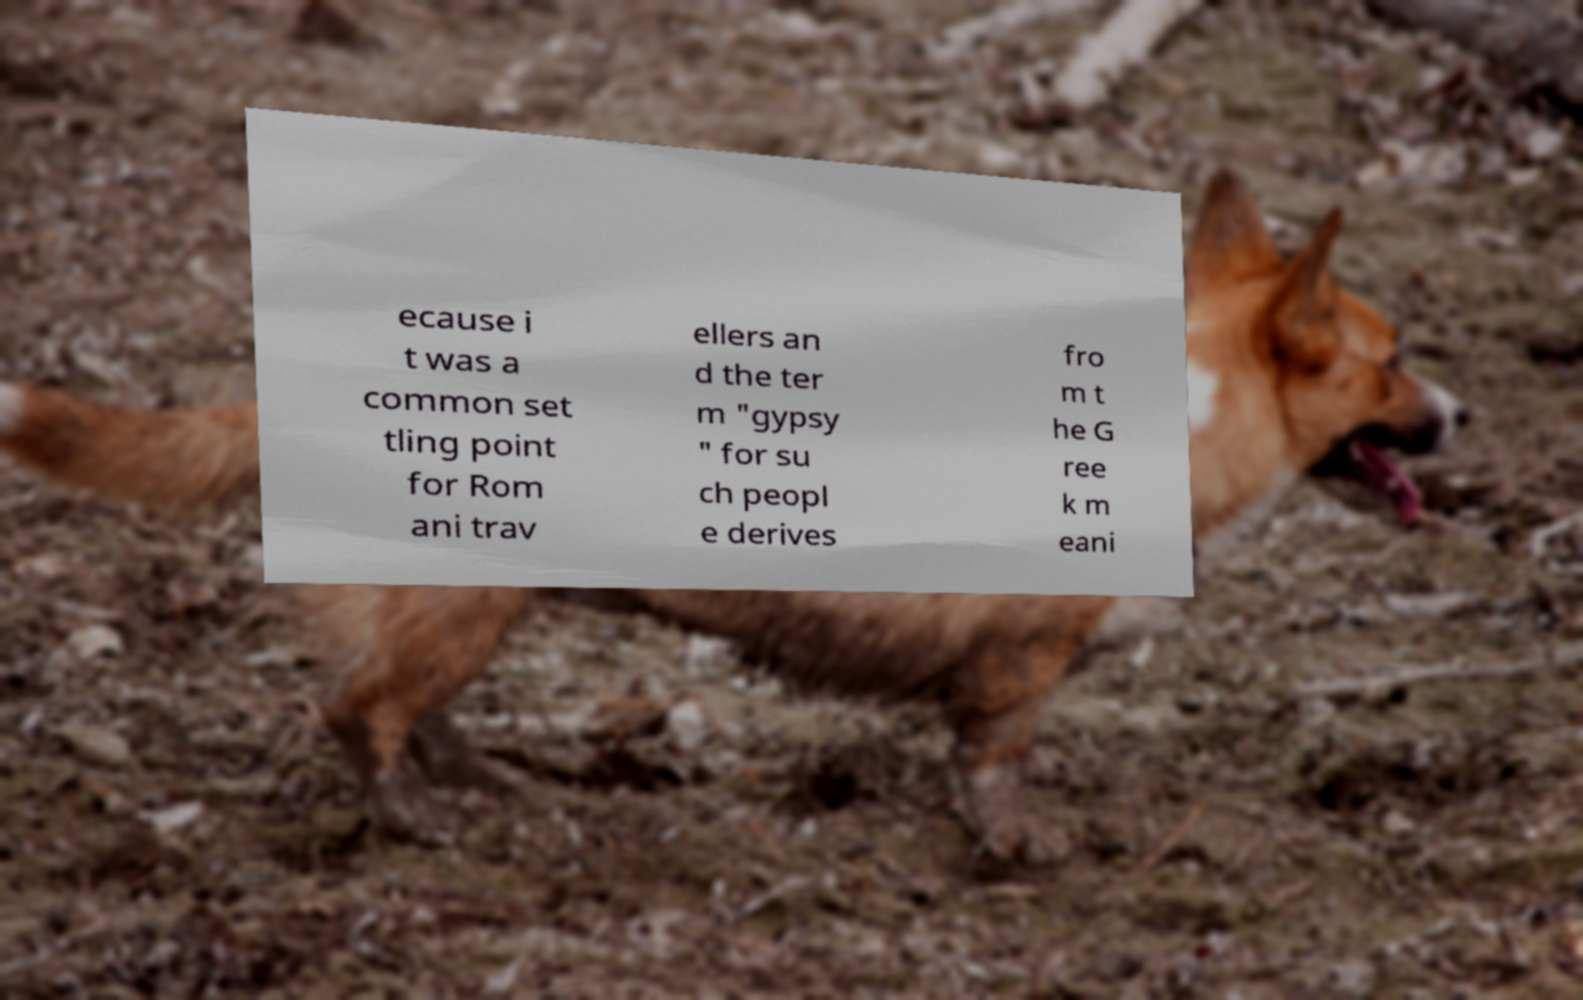Could you extract and type out the text from this image? ecause i t was a common set tling point for Rom ani trav ellers an d the ter m "gypsy " for su ch peopl e derives fro m t he G ree k m eani 